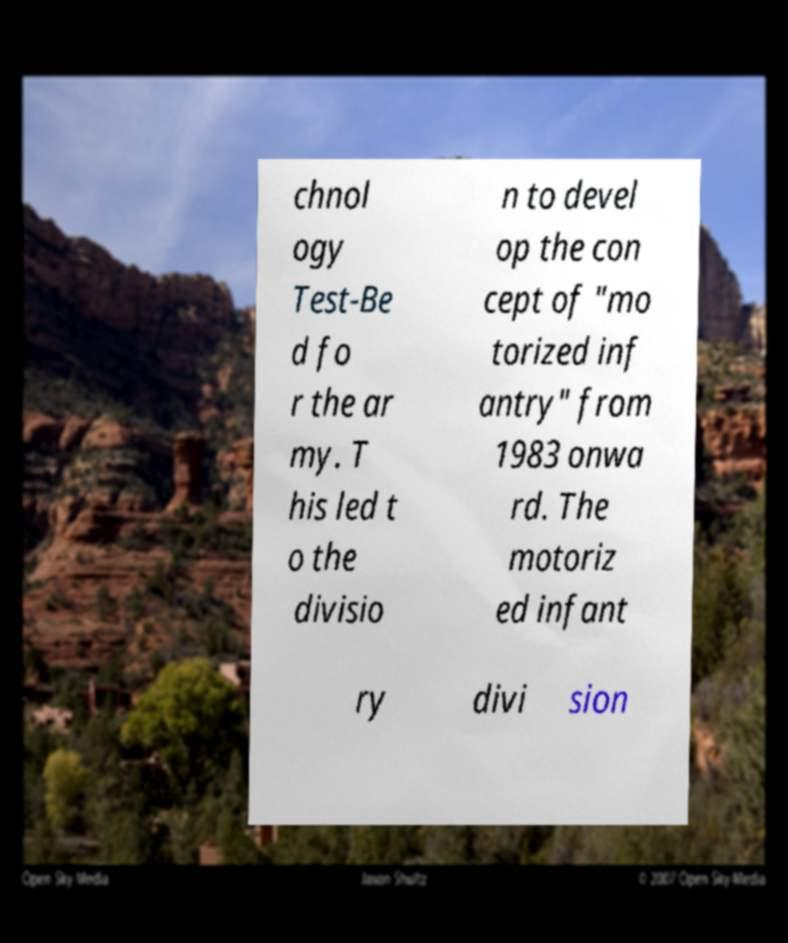Please read and relay the text visible in this image. What does it say? chnol ogy Test-Be d fo r the ar my. T his led t o the divisio n to devel op the con cept of "mo torized inf antry" from 1983 onwa rd. The motoriz ed infant ry divi sion 